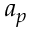Convert formula to latex. <formula><loc_0><loc_0><loc_500><loc_500>a _ { p }</formula> 